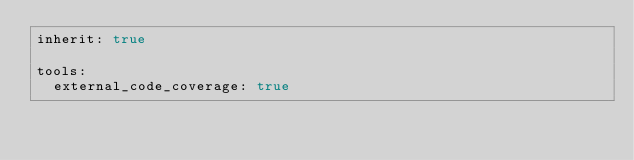Convert code to text. <code><loc_0><loc_0><loc_500><loc_500><_YAML_>inherit: true

tools:
  external_code_coverage: true
</code> 